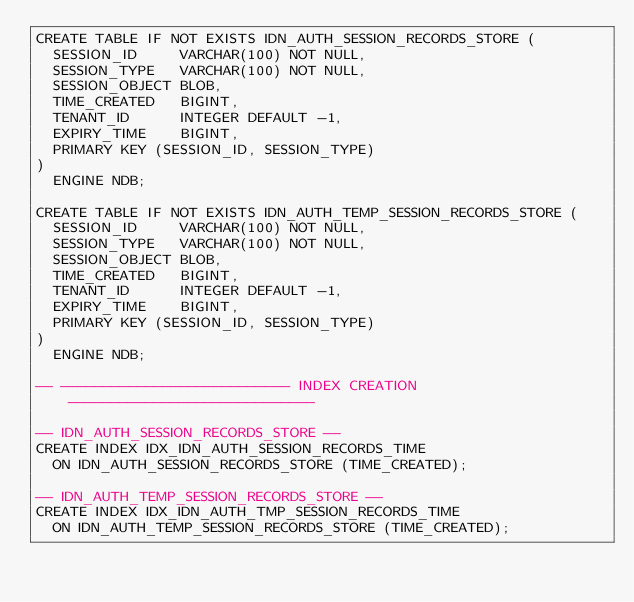<code> <loc_0><loc_0><loc_500><loc_500><_SQL_>CREATE TABLE IF NOT EXISTS IDN_AUTH_SESSION_RECORDS_STORE (
  SESSION_ID     VARCHAR(100) NOT NULL,
  SESSION_TYPE   VARCHAR(100) NOT NULL,
  SESSION_OBJECT BLOB,
  TIME_CREATED   BIGINT,
  TENANT_ID      INTEGER DEFAULT -1,
  EXPIRY_TIME    BIGINT,
  PRIMARY KEY (SESSION_ID, SESSION_TYPE)
)
  ENGINE NDB;

CREATE TABLE IF NOT EXISTS IDN_AUTH_TEMP_SESSION_RECORDS_STORE (
  SESSION_ID     VARCHAR(100) NOT NULL,
  SESSION_TYPE   VARCHAR(100) NOT NULL,
  SESSION_OBJECT BLOB,
  TIME_CREATED   BIGINT,
  TENANT_ID      INTEGER DEFAULT -1,
  EXPIRY_TIME    BIGINT,
  PRIMARY KEY (SESSION_ID, SESSION_TYPE)
)
  ENGINE NDB;

-- --------------------------- INDEX CREATION -----------------------------

-- IDN_AUTH_SESSION_RECORDS_STORE --
CREATE INDEX IDX_IDN_AUTH_SESSION_RECORDS_TIME
  ON IDN_AUTH_SESSION_RECORDS_STORE (TIME_CREATED);

-- IDN_AUTH_TEMP_SESSION_RECORDS_STORE --
CREATE INDEX IDX_IDN_AUTH_TMP_SESSION_RECORDS_TIME
  ON IDN_AUTH_TEMP_SESSION_RECORDS_STORE (TIME_CREATED);</code> 